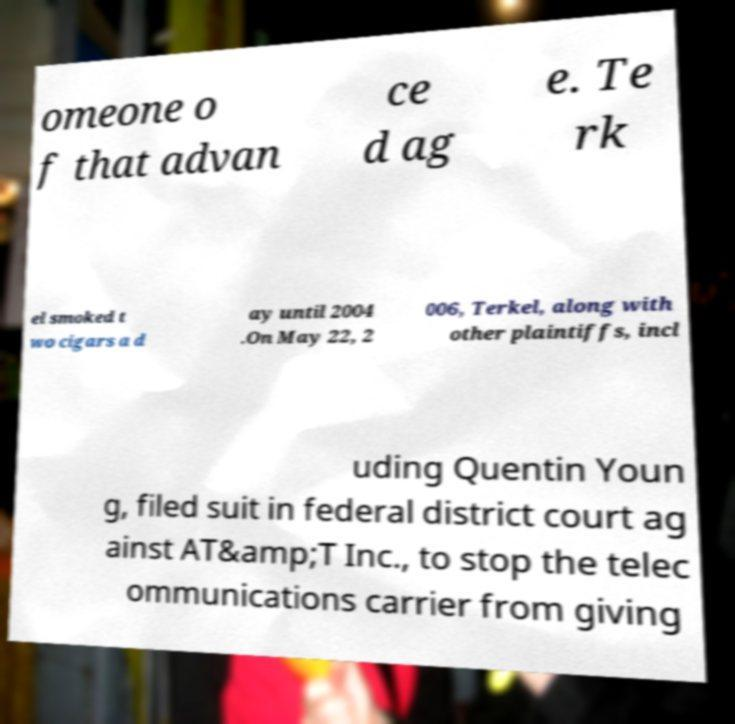There's text embedded in this image that I need extracted. Can you transcribe it verbatim? omeone o f that advan ce d ag e. Te rk el smoked t wo cigars a d ay until 2004 .On May 22, 2 006, Terkel, along with other plaintiffs, incl uding Quentin Youn g, filed suit in federal district court ag ainst AT&amp;T Inc., to stop the telec ommunications carrier from giving 